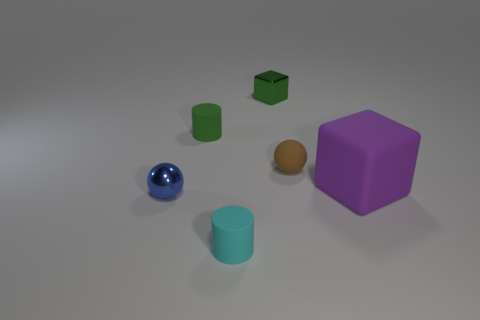Does the small cyan rubber thing have the same shape as the large purple thing?
Give a very brief answer. No. What number of objects are either rubber cylinders behind the metallic sphere or tiny cyan shiny blocks?
Ensure brevity in your answer.  1. What size is the green thing that is made of the same material as the purple cube?
Give a very brief answer. Small. How many large cylinders are the same color as the tiny cube?
Your answer should be compact. 0. How many large things are blue balls or matte cylinders?
Your answer should be very brief. 0. There is a rubber thing that is the same color as the small metal block; what size is it?
Ensure brevity in your answer.  Small. Are there any tiny blue things that have the same material as the large purple cube?
Your response must be concise. No. What material is the small ball to the left of the small rubber sphere?
Provide a short and direct response. Metal. Does the small metallic thing that is behind the purple thing have the same color as the matte thing that is in front of the blue sphere?
Make the answer very short. No. The other matte cylinder that is the same size as the cyan rubber cylinder is what color?
Keep it short and to the point. Green. 